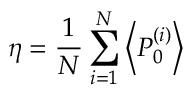Convert formula to latex. <formula><loc_0><loc_0><loc_500><loc_500>\eta = \frac { 1 } { N } \sum _ { i = 1 } ^ { N } \left < P _ { 0 } ^ { ( i ) } \right ></formula> 